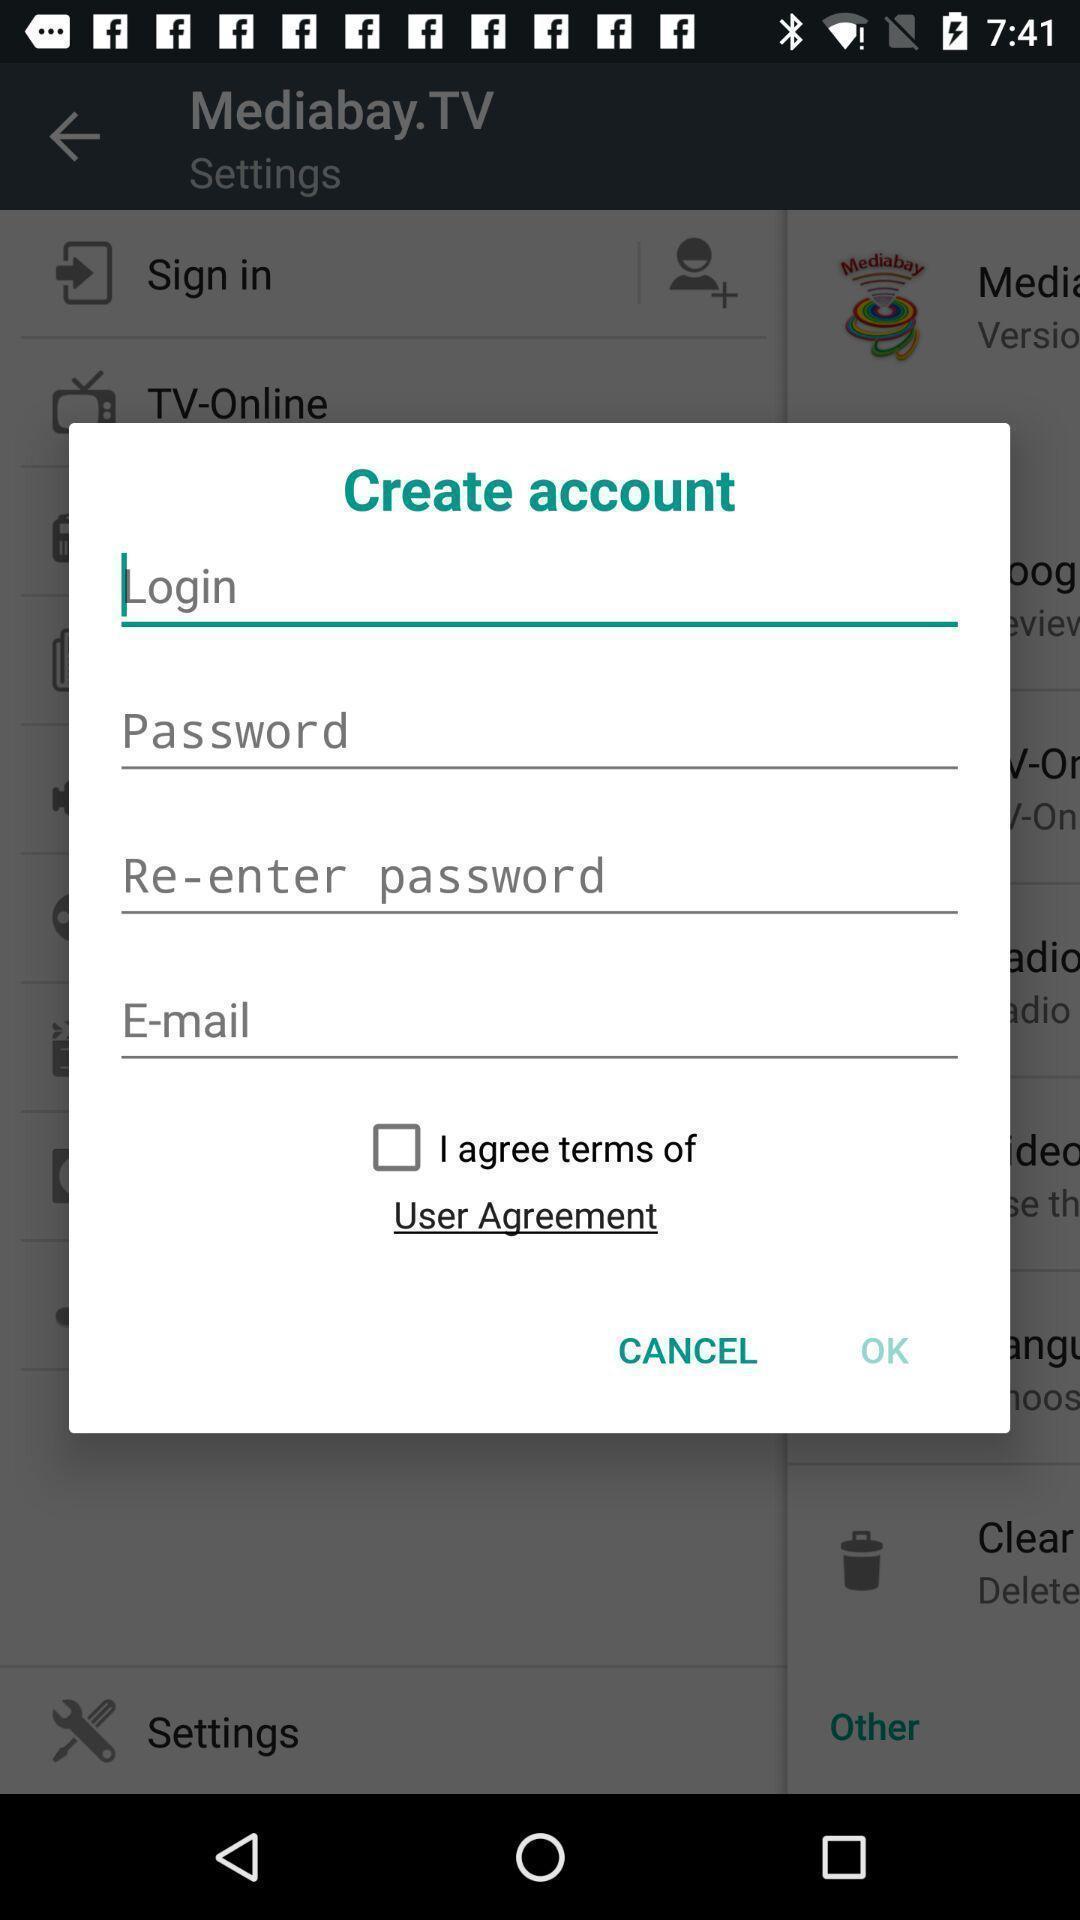Tell me about the visual elements in this screen capture. Pop-up with account creation options in a streaming related app. 